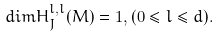Convert formula to latex. <formula><loc_0><loc_0><loc_500><loc_500>d i m H _ { J } ^ { l , l } ( M ) = 1 , ( 0 \leq l \leq d ) .</formula> 